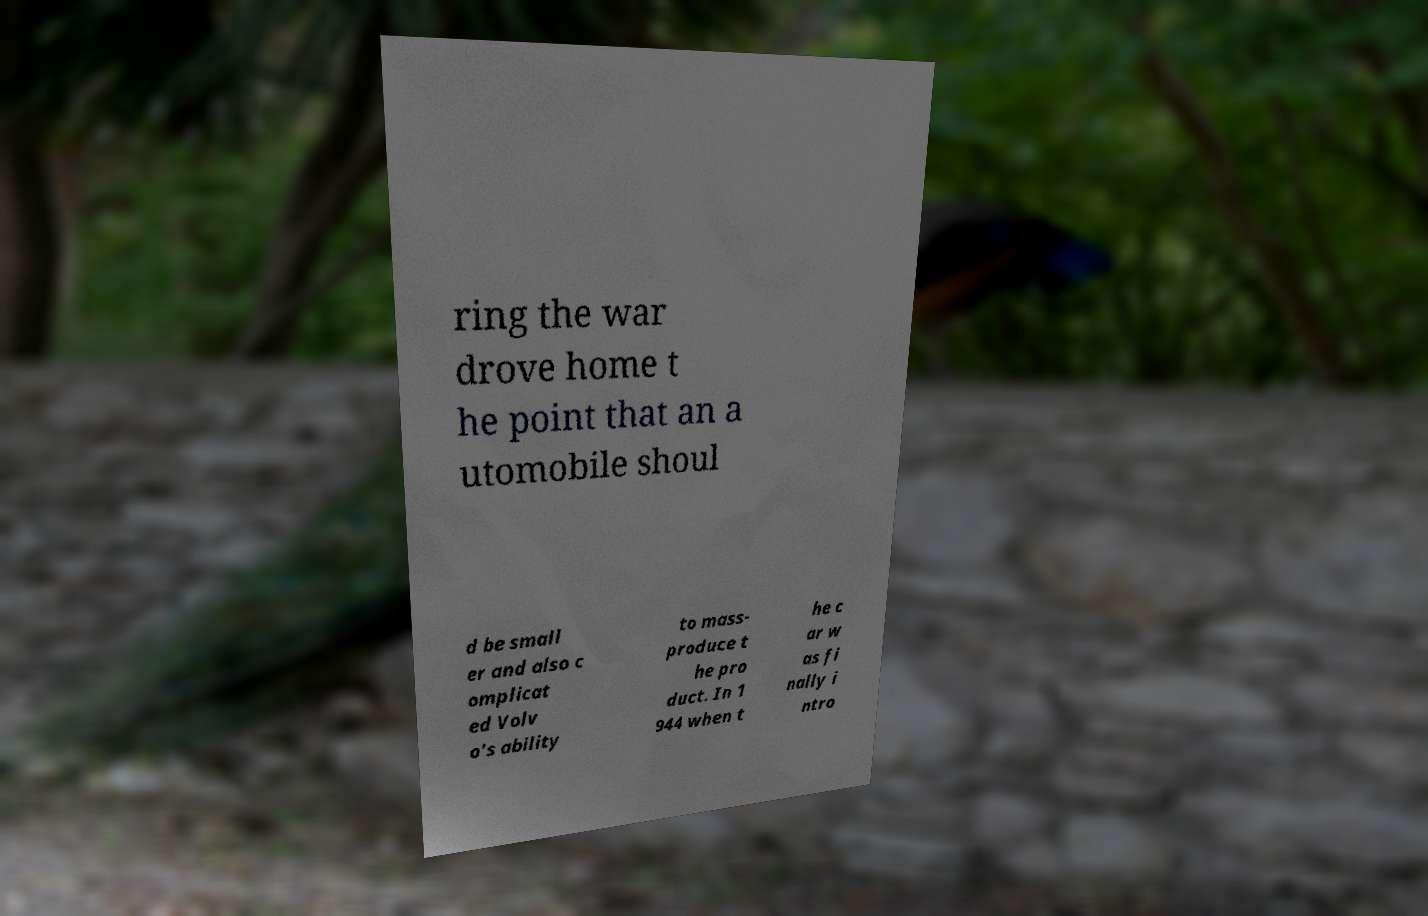For documentation purposes, I need the text within this image transcribed. Could you provide that? ring the war drove home t he point that an a utomobile shoul d be small er and also c omplicat ed Volv o's ability to mass- produce t he pro duct. In 1 944 when t he c ar w as fi nally i ntro 